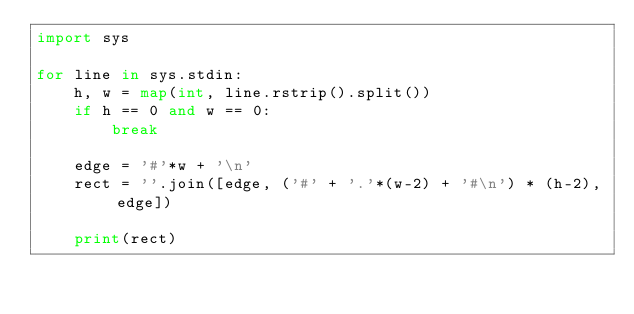<code> <loc_0><loc_0><loc_500><loc_500><_Python_>import sys

for line in sys.stdin:
    h, w = map(int, line.rstrip().split())
    if h == 0 and w == 0:
        break

    edge = '#'*w + '\n'
    rect = ''.join([edge, ('#' + '.'*(w-2) + '#\n') * (h-2), edge])

    print(rect)</code> 